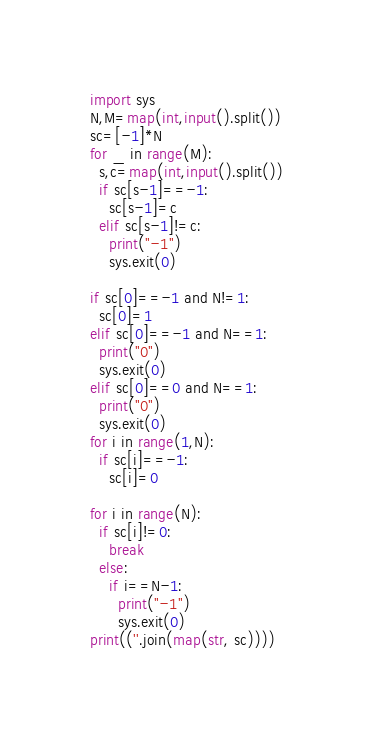Convert code to text. <code><loc_0><loc_0><loc_500><loc_500><_Python_>import sys
N,M=map(int,input().split())
sc=[-1]*N
for _ in range(M):
  s,c=map(int,input().split())
  if sc[s-1]==-1:
    sc[s-1]=c
  elif sc[s-1]!=c:
    print("-1")
    sys.exit(0)
    
if sc[0]==-1 and N!=1:
  sc[0]=1
elif sc[0]==-1 and N==1:
  print("0")
  sys.exit(0)
elif sc[0]==0 and N==1:
  print("0")
  sys.exit(0)
for i in range(1,N):
  if sc[i]==-1:
    sc[i]=0

for i in range(N):
  if sc[i]!=0:
    break
  else:
    if i==N-1:
      print("-1")
      sys.exit(0)
print((''.join(map(str, sc))))
</code> 